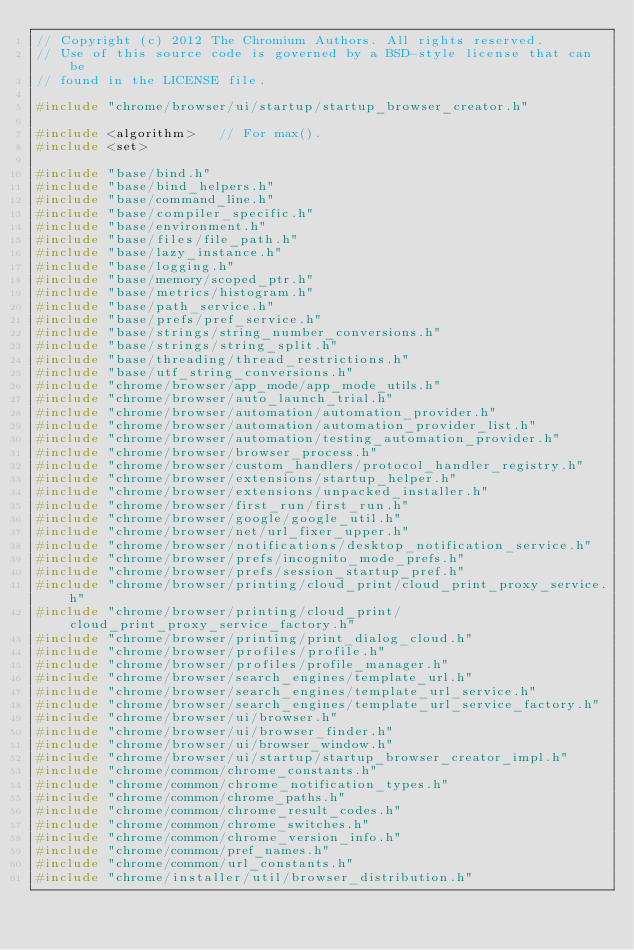<code> <loc_0><loc_0><loc_500><loc_500><_C++_>// Copyright (c) 2012 The Chromium Authors. All rights reserved.
// Use of this source code is governed by a BSD-style license that can be
// found in the LICENSE file.

#include "chrome/browser/ui/startup/startup_browser_creator.h"

#include <algorithm>   // For max().
#include <set>

#include "base/bind.h"
#include "base/bind_helpers.h"
#include "base/command_line.h"
#include "base/compiler_specific.h"
#include "base/environment.h"
#include "base/files/file_path.h"
#include "base/lazy_instance.h"
#include "base/logging.h"
#include "base/memory/scoped_ptr.h"
#include "base/metrics/histogram.h"
#include "base/path_service.h"
#include "base/prefs/pref_service.h"
#include "base/strings/string_number_conversions.h"
#include "base/strings/string_split.h"
#include "base/threading/thread_restrictions.h"
#include "base/utf_string_conversions.h"
#include "chrome/browser/app_mode/app_mode_utils.h"
#include "chrome/browser/auto_launch_trial.h"
#include "chrome/browser/automation/automation_provider.h"
#include "chrome/browser/automation/automation_provider_list.h"
#include "chrome/browser/automation/testing_automation_provider.h"
#include "chrome/browser/browser_process.h"
#include "chrome/browser/custom_handlers/protocol_handler_registry.h"
#include "chrome/browser/extensions/startup_helper.h"
#include "chrome/browser/extensions/unpacked_installer.h"
#include "chrome/browser/first_run/first_run.h"
#include "chrome/browser/google/google_util.h"
#include "chrome/browser/net/url_fixer_upper.h"
#include "chrome/browser/notifications/desktop_notification_service.h"
#include "chrome/browser/prefs/incognito_mode_prefs.h"
#include "chrome/browser/prefs/session_startup_pref.h"
#include "chrome/browser/printing/cloud_print/cloud_print_proxy_service.h"
#include "chrome/browser/printing/cloud_print/cloud_print_proxy_service_factory.h"
#include "chrome/browser/printing/print_dialog_cloud.h"
#include "chrome/browser/profiles/profile.h"
#include "chrome/browser/profiles/profile_manager.h"
#include "chrome/browser/search_engines/template_url.h"
#include "chrome/browser/search_engines/template_url_service.h"
#include "chrome/browser/search_engines/template_url_service_factory.h"
#include "chrome/browser/ui/browser.h"
#include "chrome/browser/ui/browser_finder.h"
#include "chrome/browser/ui/browser_window.h"
#include "chrome/browser/ui/startup/startup_browser_creator_impl.h"
#include "chrome/common/chrome_constants.h"
#include "chrome/common/chrome_notification_types.h"
#include "chrome/common/chrome_paths.h"
#include "chrome/common/chrome_result_codes.h"
#include "chrome/common/chrome_switches.h"
#include "chrome/common/chrome_version_info.h"
#include "chrome/common/pref_names.h"
#include "chrome/common/url_constants.h"
#include "chrome/installer/util/browser_distribution.h"</code> 